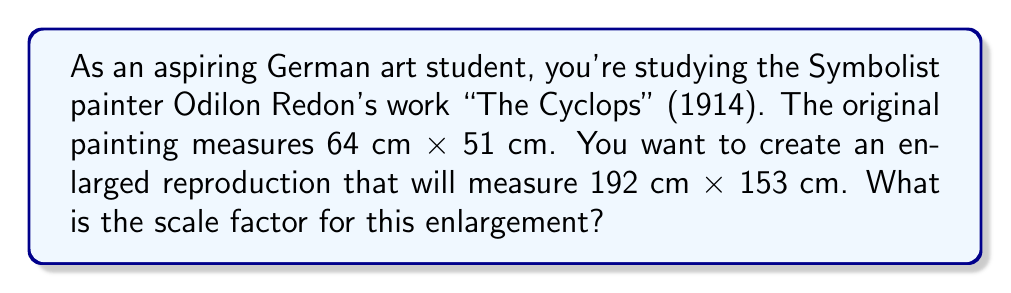Can you answer this question? To determine the scale factor for enlarging a painting, we need to compare the new dimensions to the original dimensions. We can do this by dividing the new measurement by the original measurement for either the width or the height.

Let's calculate using both dimensions to verify:

1. Using the width:
   $\text{Scale factor} = \frac{\text{New width}}{\text{Original width}} = \frac{192 \text{ cm}}{64 \text{ cm}} = 3$

2. Using the height:
   $\text{Scale factor} = \frac{\text{New height}}{\text{Original height}} = \frac{153 \text{ cm}}{51 \text{ cm}} = 3$

Both calculations yield the same result, confirming that the enlargement is proportional.

The scale factor can also be expressed as a ratio:
$\text{Scale factor} = 3:1$

This means that for every 1 unit in the original painting, there will be 3 units in the enlarged version.

To verify, we can multiply the original dimensions by the scale factor:
$64 \text{ cm} \times 3 = 192 \text{ cm}$
$51 \text{ cm} \times 3 = 153 \text{ cm}$

These calculations confirm that a scale factor of 3 will produce the desired enlargement.
Answer: The scale factor for enlarging the painting is $3$ or $3:1$. 